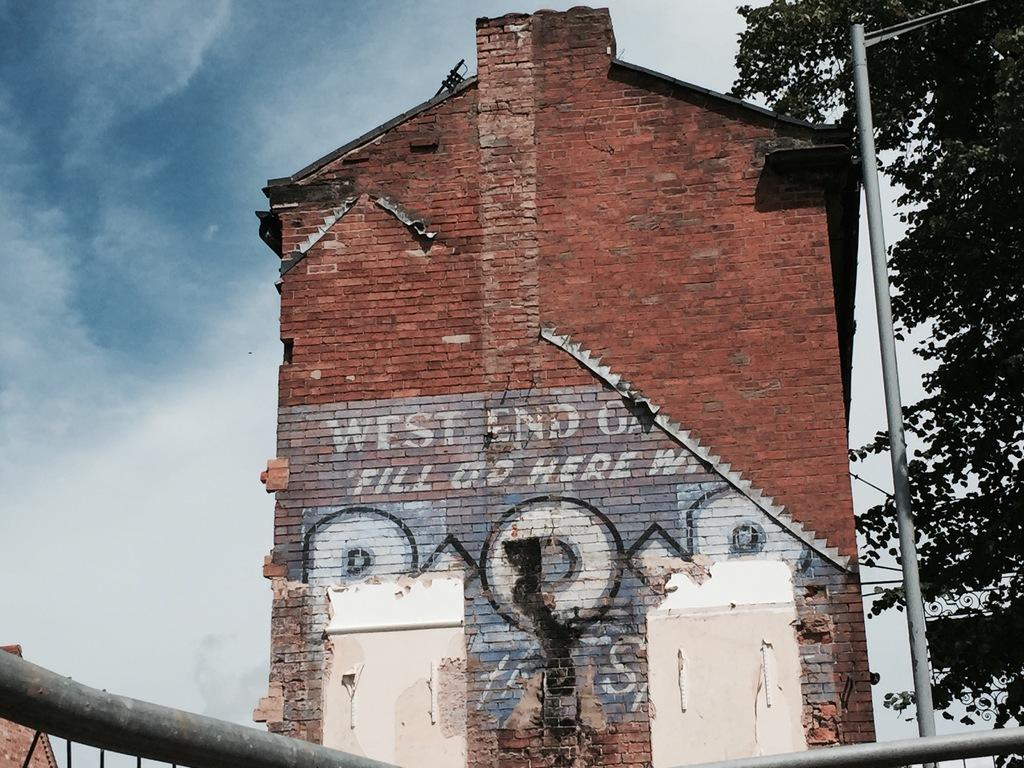What type of structures can be seen in the image? There are buildings in the image. What type of natural elements are present in the image? There are trees in the image. What type of man-made objects can be seen in the image? There are poles in the image. What is visible in the background of the image? The sky is visible in the image. What type of religious symbol can be seen hanging from the poles in the image? There is no religious symbol hanging from the poles in the image. What type of jewel can be seen embedded in the buildings in the image? There is no jewel present in the image. What type of woolen clothing can be seen worn by the trees in the image? There is no woolen clothing present in the image. 